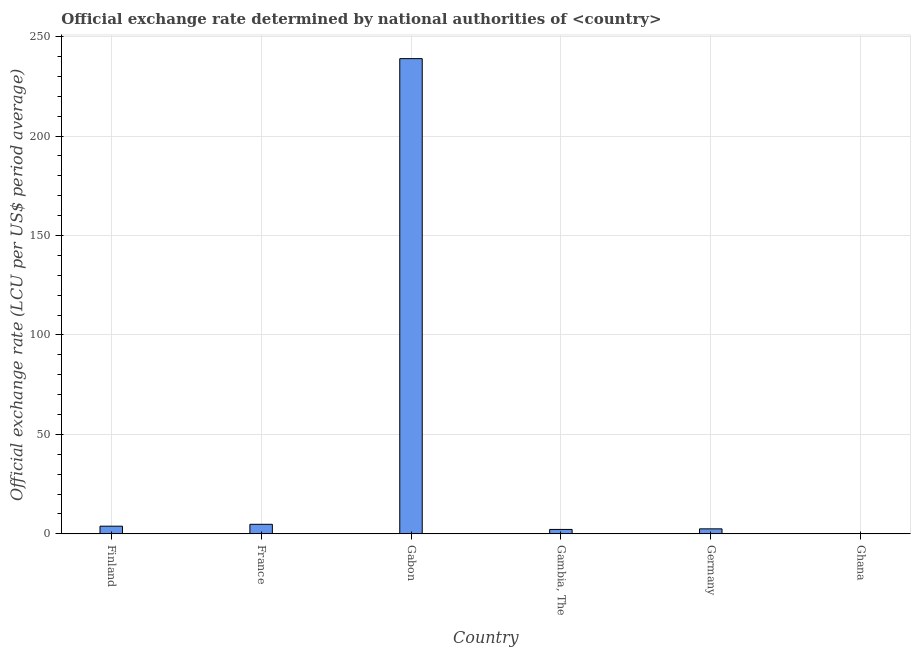Does the graph contain any zero values?
Your response must be concise. No. Does the graph contain grids?
Give a very brief answer. Yes. What is the title of the graph?
Ensure brevity in your answer.  Official exchange rate determined by national authorities of <country>. What is the label or title of the Y-axis?
Offer a very short reply. Official exchange rate (LCU per US$ period average). What is the official exchange rate in France?
Provide a succinct answer. 4.8. Across all countries, what is the maximum official exchange rate?
Your answer should be compact. 238.95. Across all countries, what is the minimum official exchange rate?
Provide a succinct answer. 0. In which country was the official exchange rate maximum?
Your answer should be very brief. Gabon. In which country was the official exchange rate minimum?
Ensure brevity in your answer.  Ghana. What is the sum of the official exchange rate?
Offer a very short reply. 252.36. What is the difference between the official exchange rate in Gambia, The and Germany?
Your response must be concise. -0.29. What is the average official exchange rate per country?
Your answer should be very brief. 42.06. What is the median official exchange rate?
Provide a short and direct response. 3.19. What is the ratio of the official exchange rate in France to that in Ghana?
Ensure brevity in your answer.  4.18e+04. What is the difference between the highest and the second highest official exchange rate?
Your answer should be very brief. 234.15. What is the difference between the highest and the lowest official exchange rate?
Keep it short and to the point. 238.95. How many bars are there?
Provide a succinct answer. 6. What is the difference between two consecutive major ticks on the Y-axis?
Offer a terse response. 50. Are the values on the major ticks of Y-axis written in scientific E-notation?
Give a very brief answer. No. What is the Official exchange rate (LCU per US$ period average) in Finland?
Offer a terse response. 3.86. What is the Official exchange rate (LCU per US$ period average) of France?
Your answer should be compact. 4.8. What is the Official exchange rate (LCU per US$ period average) in Gabon?
Give a very brief answer. 238.95. What is the Official exchange rate (LCU per US$ period average) of Gambia, The?
Provide a succinct answer. 2.23. What is the Official exchange rate (LCU per US$ period average) in Germany?
Your answer should be very brief. 2.52. What is the Official exchange rate (LCU per US$ period average) of Ghana?
Offer a terse response. 0. What is the difference between the Official exchange rate (LCU per US$ period average) in Finland and France?
Your answer should be very brief. -0.94. What is the difference between the Official exchange rate (LCU per US$ period average) in Finland and Gabon?
Make the answer very short. -235.09. What is the difference between the Official exchange rate (LCU per US$ period average) in Finland and Gambia, The?
Make the answer very short. 1.64. What is the difference between the Official exchange rate (LCU per US$ period average) in Finland and Germany?
Make the answer very short. 1.35. What is the difference between the Official exchange rate (LCU per US$ period average) in Finland and Ghana?
Give a very brief answer. 3.86. What is the difference between the Official exchange rate (LCU per US$ period average) in France and Gabon?
Offer a very short reply. -234.15. What is the difference between the Official exchange rate (LCU per US$ period average) in France and Gambia, The?
Give a very brief answer. 2.58. What is the difference between the Official exchange rate (LCU per US$ period average) in France and Germany?
Provide a short and direct response. 2.28. What is the difference between the Official exchange rate (LCU per US$ period average) in France and Ghana?
Your answer should be very brief. 4.8. What is the difference between the Official exchange rate (LCU per US$ period average) in Gabon and Gambia, The?
Offer a very short reply. 236.72. What is the difference between the Official exchange rate (LCU per US$ period average) in Gabon and Germany?
Your answer should be very brief. 236.43. What is the difference between the Official exchange rate (LCU per US$ period average) in Gabon and Ghana?
Make the answer very short. 238.95. What is the difference between the Official exchange rate (LCU per US$ period average) in Gambia, The and Germany?
Keep it short and to the point. -0.29. What is the difference between the Official exchange rate (LCU per US$ period average) in Gambia, The and Ghana?
Your answer should be very brief. 2.23. What is the difference between the Official exchange rate (LCU per US$ period average) in Germany and Ghana?
Ensure brevity in your answer.  2.52. What is the ratio of the Official exchange rate (LCU per US$ period average) in Finland to that in France?
Keep it short and to the point. 0.81. What is the ratio of the Official exchange rate (LCU per US$ period average) in Finland to that in Gabon?
Ensure brevity in your answer.  0.02. What is the ratio of the Official exchange rate (LCU per US$ period average) in Finland to that in Gambia, The?
Make the answer very short. 1.74. What is the ratio of the Official exchange rate (LCU per US$ period average) in Finland to that in Germany?
Offer a very short reply. 1.53. What is the ratio of the Official exchange rate (LCU per US$ period average) in Finland to that in Ghana?
Provide a short and direct response. 3.36e+04. What is the ratio of the Official exchange rate (LCU per US$ period average) in France to that in Gabon?
Your answer should be very brief. 0.02. What is the ratio of the Official exchange rate (LCU per US$ period average) in France to that in Gambia, The?
Offer a very short reply. 2.16. What is the ratio of the Official exchange rate (LCU per US$ period average) in France to that in Germany?
Your answer should be compact. 1.91. What is the ratio of the Official exchange rate (LCU per US$ period average) in France to that in Ghana?
Your answer should be compact. 4.18e+04. What is the ratio of the Official exchange rate (LCU per US$ period average) in Gabon to that in Gambia, The?
Provide a succinct answer. 107.36. What is the ratio of the Official exchange rate (LCU per US$ period average) in Gabon to that in Germany?
Keep it short and to the point. 94.9. What is the ratio of the Official exchange rate (LCU per US$ period average) in Gabon to that in Ghana?
Provide a succinct answer. 2.08e+06. What is the ratio of the Official exchange rate (LCU per US$ period average) in Gambia, The to that in Germany?
Your answer should be compact. 0.88. What is the ratio of the Official exchange rate (LCU per US$ period average) in Gambia, The to that in Ghana?
Your answer should be very brief. 1.94e+04. What is the ratio of the Official exchange rate (LCU per US$ period average) in Germany to that in Ghana?
Make the answer very short. 2.19e+04. 